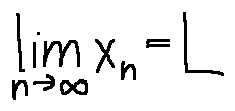Convert formula to latex. <formula><loc_0><loc_0><loc_500><loc_500>\lim \lim i t s _ { n \rightarrow \infty } x _ { n } = L</formula> 